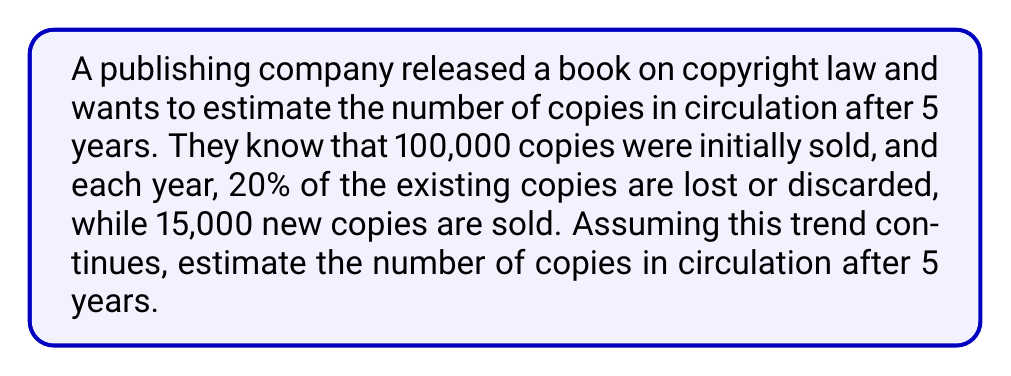Could you help me with this problem? Let's approach this step-by-step:

1) Let $N_t$ be the number of copies in circulation after $t$ years.

2) We start with $N_0 = 100,000$ copies.

3) Each year, we lose 20% of existing copies and gain 15,000 new ones. This can be represented by the equation:

   $N_{t+1} = 0.8N_t + 15,000$

4) Let's calculate for each year:

   Year 1: $N_1 = 0.8(100,000) + 15,000 = 95,000$
   Year 2: $N_2 = 0.8(95,000) + 15,000 = 91,000$
   Year 3: $N_3 = 0.8(91,000) + 15,000 = 87,800$
   Year 4: $N_4 = 0.8(87,800) + 15,000 = 85,240$
   Year 5: $N_5 = 0.8(85,240) + 15,000 = 83,192$

5) We can also derive a general formula:

   $N_t = 75,000 - 25,000(0.8)^t$

6) Plugging in $t=5$:

   $N_5 = 75,000 - 25,000(0.8)^5 = 75,000 - 25,000(0.32768) = 83,192$

This confirms our step-by-step calculation.
Answer: 83,192 copies 